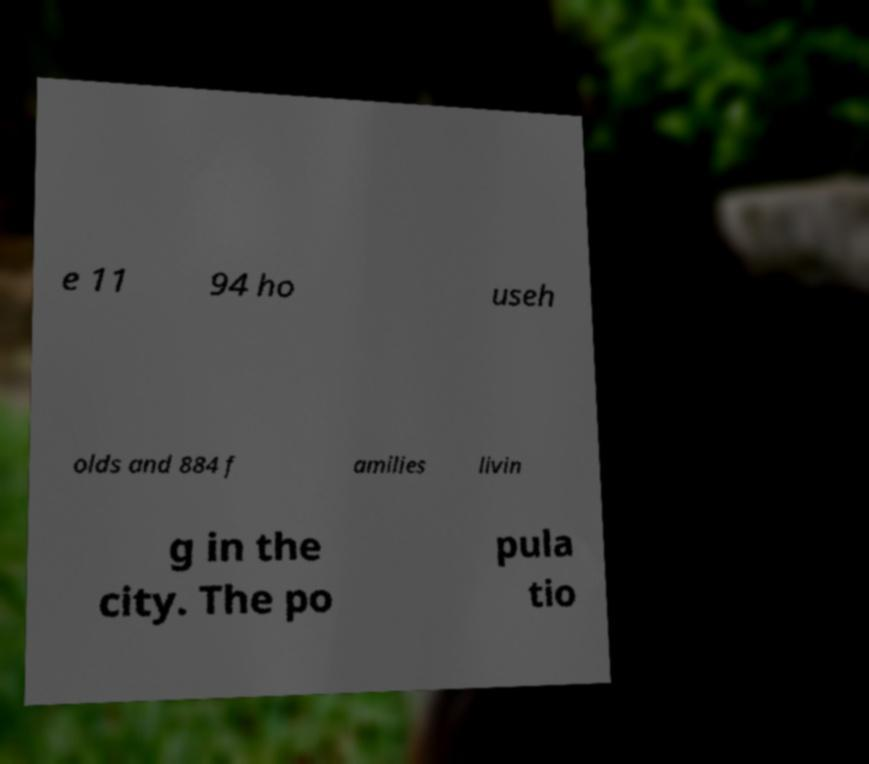Could you assist in decoding the text presented in this image and type it out clearly? e 11 94 ho useh olds and 884 f amilies livin g in the city. The po pula tio 